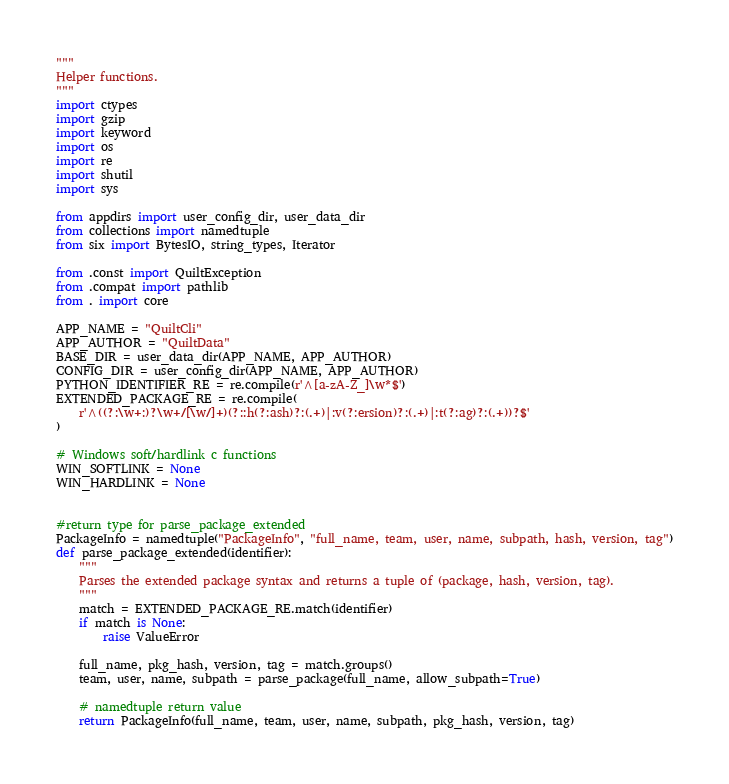<code> <loc_0><loc_0><loc_500><loc_500><_Python_>"""
Helper functions.
"""
import ctypes
import gzip
import keyword
import os
import re
import shutil
import sys

from appdirs import user_config_dir, user_data_dir
from collections import namedtuple
from six import BytesIO, string_types, Iterator

from .const import QuiltException
from .compat import pathlib
from . import core

APP_NAME = "QuiltCli"
APP_AUTHOR = "QuiltData"
BASE_DIR = user_data_dir(APP_NAME, APP_AUTHOR)
CONFIG_DIR = user_config_dir(APP_NAME, APP_AUTHOR)
PYTHON_IDENTIFIER_RE = re.compile(r'^[a-zA-Z_]\w*$')
EXTENDED_PACKAGE_RE = re.compile(
    r'^((?:\w+:)?\w+/[\w/]+)(?::h(?:ash)?:(.+)|:v(?:ersion)?:(.+)|:t(?:ag)?:(.+))?$'
)

# Windows soft/hardlink c functions
WIN_SOFTLINK = None
WIN_HARDLINK = None


#return type for parse_package_extended
PackageInfo = namedtuple("PackageInfo", "full_name, team, user, name, subpath, hash, version, tag")
def parse_package_extended(identifier):
    """
    Parses the extended package syntax and returns a tuple of (package, hash, version, tag).
    """
    match = EXTENDED_PACKAGE_RE.match(identifier)
    if match is None:
        raise ValueError

    full_name, pkg_hash, version, tag = match.groups()
    team, user, name, subpath = parse_package(full_name, allow_subpath=True)

    # namedtuple return value
    return PackageInfo(full_name, team, user, name, subpath, pkg_hash, version, tag)
</code> 